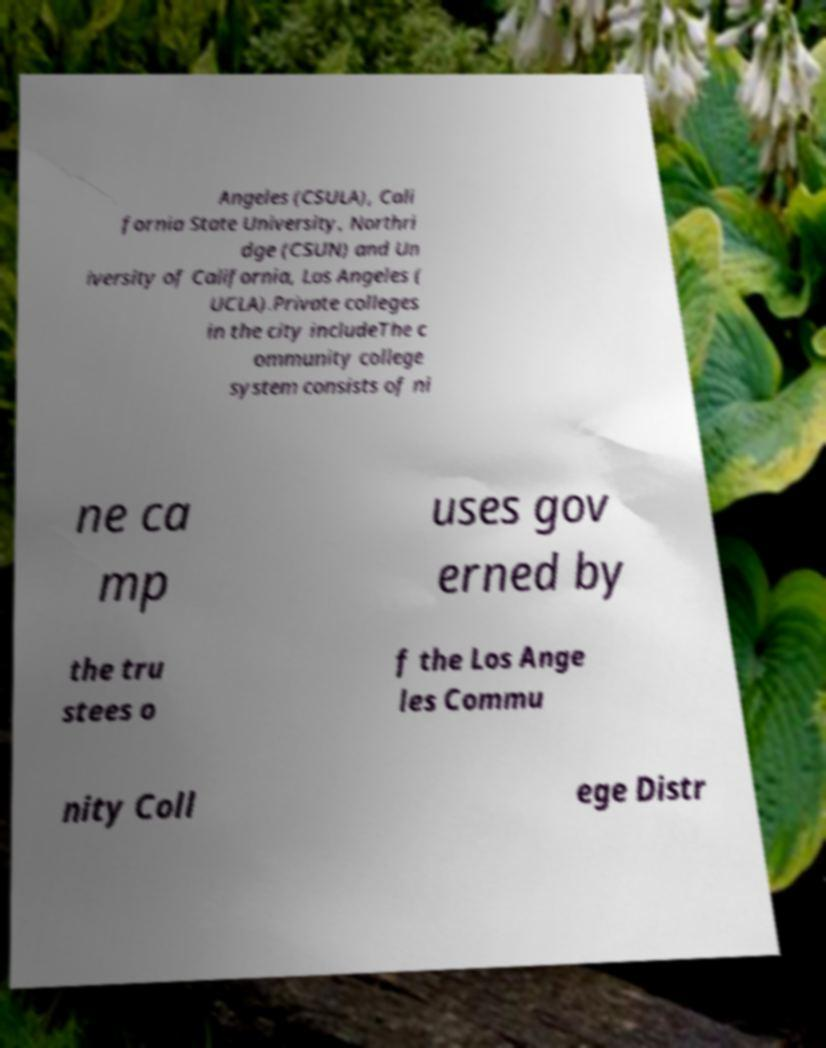Can you accurately transcribe the text from the provided image for me? Angeles (CSULA), Cali fornia State University, Northri dge (CSUN) and Un iversity of California, Los Angeles ( UCLA).Private colleges in the city includeThe c ommunity college system consists of ni ne ca mp uses gov erned by the tru stees o f the Los Ange les Commu nity Coll ege Distr 